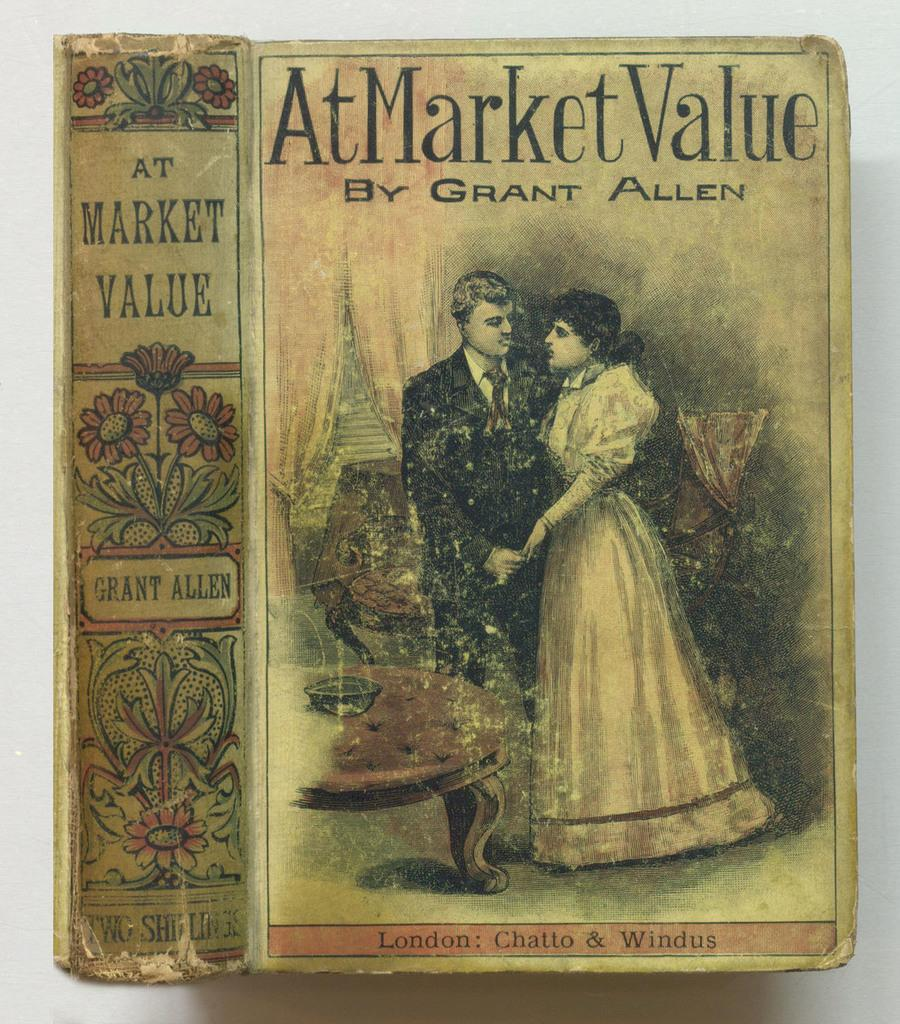<image>
Describe the image concisely. A book by Grant Allen shows a couple on the front. 